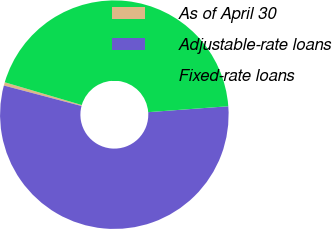<chart> <loc_0><loc_0><loc_500><loc_500><pie_chart><fcel>As of April 30<fcel>Adjustable-rate loans<fcel>Fixed-rate loans<nl><fcel>0.47%<fcel>55.28%<fcel>44.25%<nl></chart> 